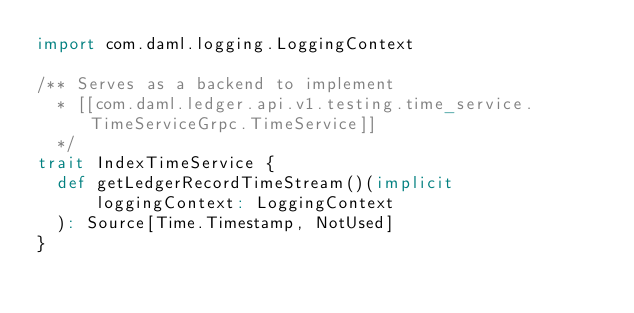Convert code to text. <code><loc_0><loc_0><loc_500><loc_500><_Scala_>import com.daml.logging.LoggingContext

/** Serves as a backend to implement
  * [[com.daml.ledger.api.v1.testing.time_service.TimeServiceGrpc.TimeService]]
  */
trait IndexTimeService {
  def getLedgerRecordTimeStream()(implicit
      loggingContext: LoggingContext
  ): Source[Time.Timestamp, NotUsed]
}
</code> 